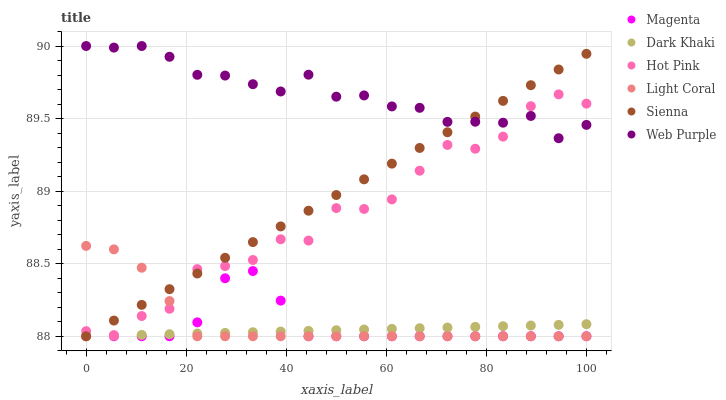Does Dark Khaki have the minimum area under the curve?
Answer yes or no. Yes. Does Web Purple have the maximum area under the curve?
Answer yes or no. Yes. Does Hot Pink have the minimum area under the curve?
Answer yes or no. No. Does Hot Pink have the maximum area under the curve?
Answer yes or no. No. Is Sienna the smoothest?
Answer yes or no. Yes. Is Hot Pink the roughest?
Answer yes or no. Yes. Is Dark Khaki the smoothest?
Answer yes or no. No. Is Dark Khaki the roughest?
Answer yes or no. No. Does Light Coral have the lowest value?
Answer yes or no. Yes. Does Hot Pink have the lowest value?
Answer yes or no. No. Does Web Purple have the highest value?
Answer yes or no. Yes. Does Hot Pink have the highest value?
Answer yes or no. No. Is Light Coral less than Web Purple?
Answer yes or no. Yes. Is Web Purple greater than Light Coral?
Answer yes or no. Yes. Does Magenta intersect Dark Khaki?
Answer yes or no. Yes. Is Magenta less than Dark Khaki?
Answer yes or no. No. Is Magenta greater than Dark Khaki?
Answer yes or no. No. Does Light Coral intersect Web Purple?
Answer yes or no. No. 